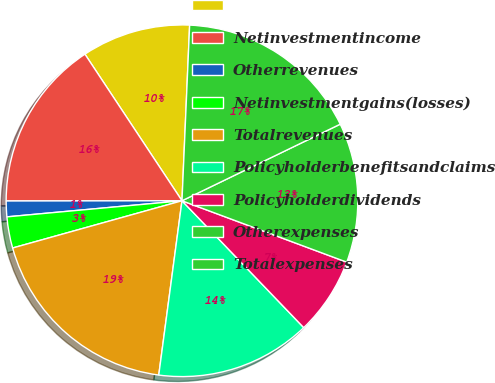Convert chart. <chart><loc_0><loc_0><loc_500><loc_500><pie_chart><ecel><fcel>Netinvestmentincome<fcel>Otherrevenues<fcel>Netinvestmentgains(losses)<fcel>Totalrevenues<fcel>Policyholderbenefitsandclaims<fcel>Policyholderdividends<fcel>Otherexpenses<fcel>Totalexpenses<nl><fcel>10.0%<fcel>15.71%<fcel>1.44%<fcel>2.87%<fcel>18.56%<fcel>14.28%<fcel>7.15%<fcel>12.85%<fcel>17.13%<nl></chart> 